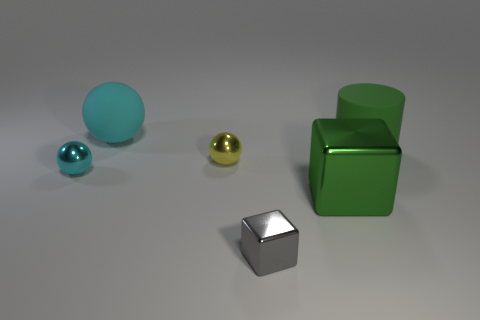Add 2 large blue metal things. How many objects exist? 8 Subtract all cylinders. How many objects are left? 5 Subtract all tiny rubber objects. Subtract all green rubber objects. How many objects are left? 5 Add 3 small gray shiny objects. How many small gray shiny objects are left? 4 Add 5 tiny objects. How many tiny objects exist? 8 Subtract 1 gray blocks. How many objects are left? 5 